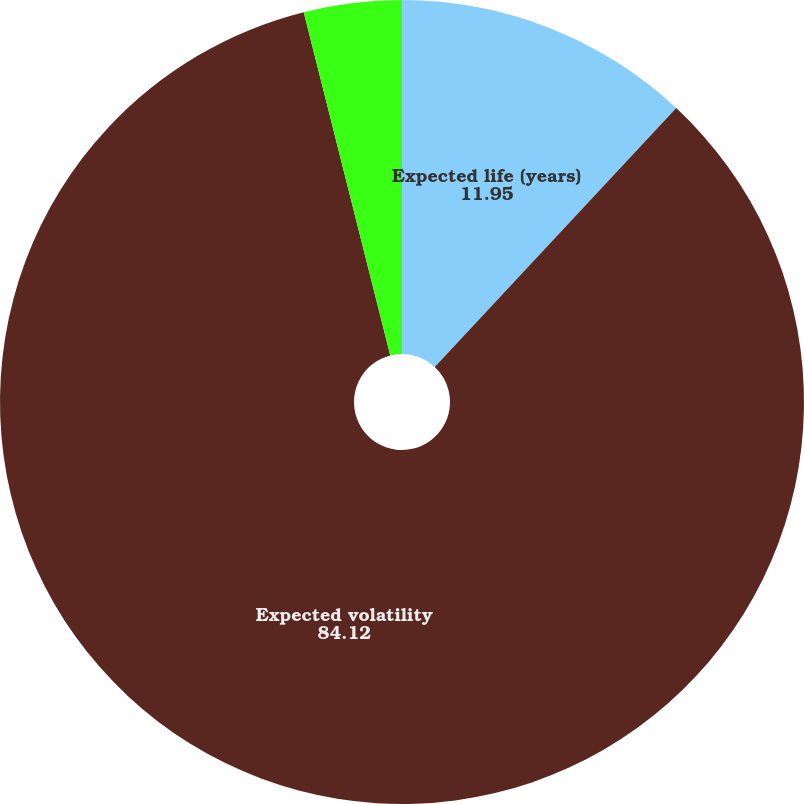Convert chart to OTSL. <chart><loc_0><loc_0><loc_500><loc_500><pie_chart><fcel>Expected life (years)<fcel>Expected volatility<fcel>Risk-free interest rate<nl><fcel>11.95%<fcel>84.12%<fcel>3.93%<nl></chart> 